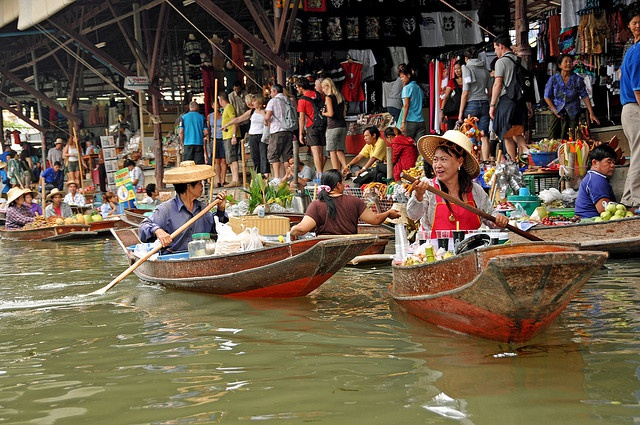Describe the objects in this image and their specific colors. I can see people in gray, black, darkgray, and maroon tones, boat in gray, maroon, brown, and black tones, boat in gray, maroon, and black tones, people in gray, black, maroon, and brown tones, and people in gray, black, and tan tones in this image. 